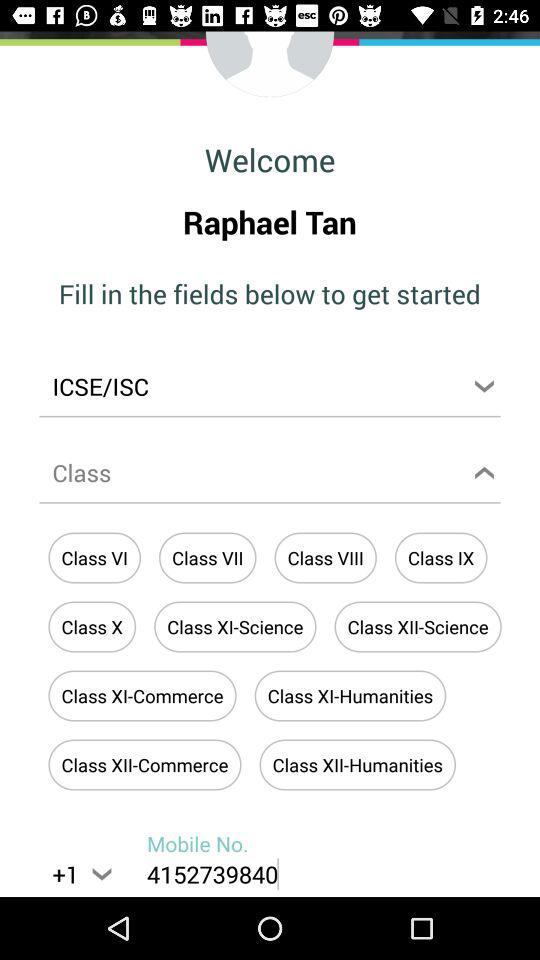What is the selected board? The selected board is "ICSE/ISC". 